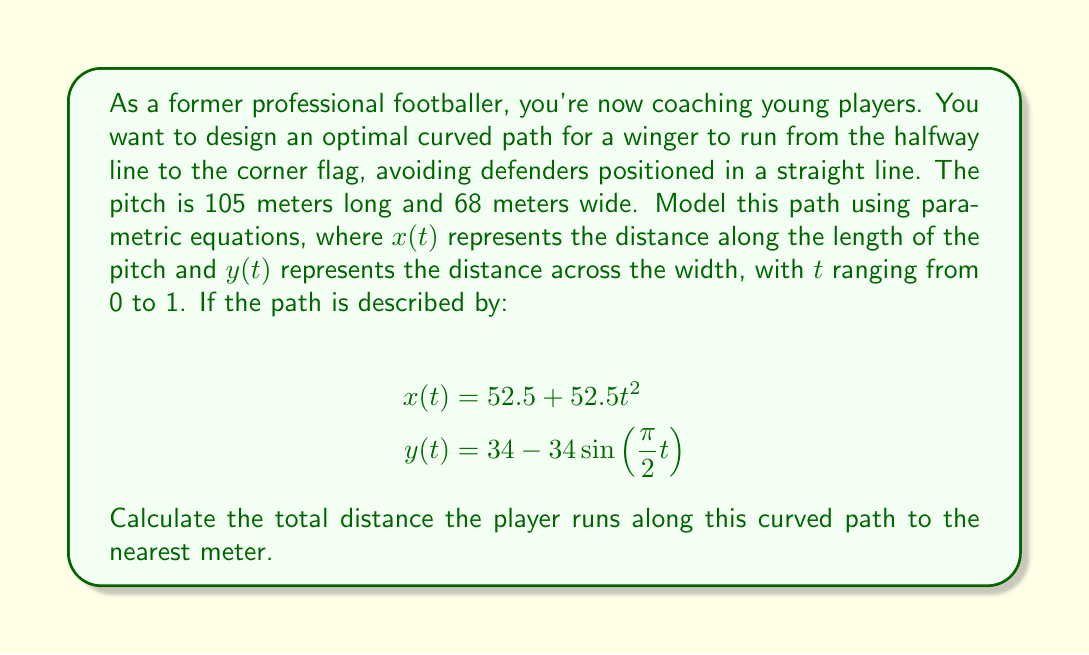Teach me how to tackle this problem. To solve this problem, we'll follow these steps:

1) The parametric equations given describe a curve from the halfway line (52.5m along the length) to the corner flag (105m along the length, 0m across the width).

2) To find the length of the curve, we need to use the arc length formula for parametric equations:

   $$L = \int_{0}^{1} \sqrt{\left(\frac{dx}{dt}\right)^2 + \left(\frac{dy}{dt}\right)^2} dt$$

3) First, let's find $\frac{dx}{dt}$ and $\frac{dy}{dt}$:

   $$\frac{dx}{dt} = 105t$$
   $$\frac{dy}{dt} = -34 \cdot \frac{\pi}{2} \cos(\frac{\pi}{2}t)$$

4) Now, let's substitute these into the arc length formula:

   $$L = \int_{0}^{1} \sqrt{(105t)^2 + (-34 \cdot \frac{\pi}{2} \cos(\frac{\pi}{2}t))^2} dt$$

5) This integral is complex and doesn't have a simple analytical solution. We need to use numerical integration methods to approximate it.

6) Using a computational tool or numerical integration method (like Simpson's rule or the trapezoidal rule with a large number of subdivisions), we can approximate this integral.

7) The result of this numerical integration is approximately 61.7 meters.

8) Rounding to the nearest meter as requested in the question, we get 62 meters.
Answer: The total distance the player runs along the curved path is approximately 62 meters. 